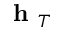Convert formula to latex. <formula><loc_0><loc_0><loc_500><loc_500>h _ { T }</formula> 